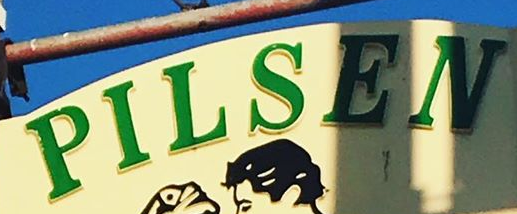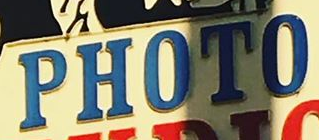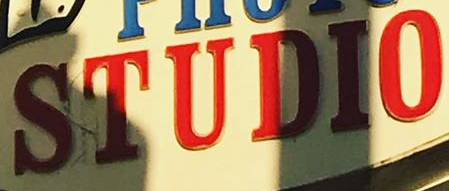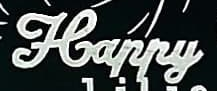Identify the words shown in these images in order, separated by a semicolon. PILSEN; PHOTO; STUDIO; Happy 